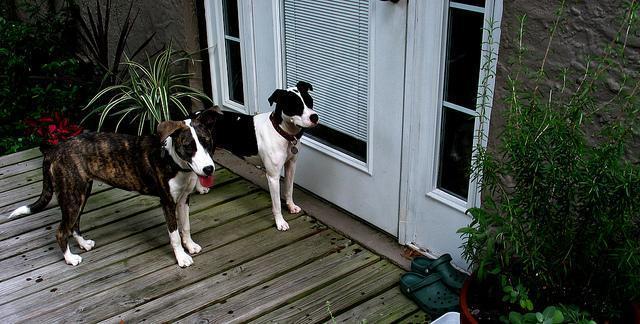How many dogs are there?
Give a very brief answer. 2. How many potted plants are in the photo?
Give a very brief answer. 2. 